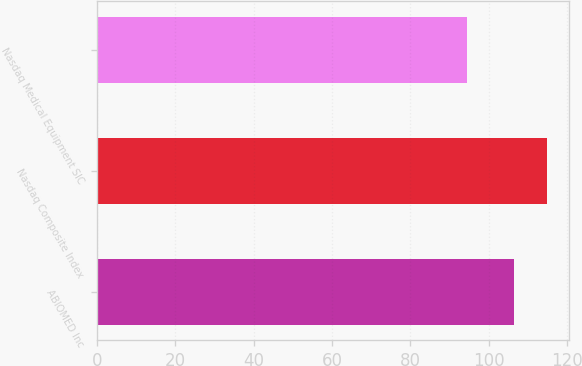<chart> <loc_0><loc_0><loc_500><loc_500><bar_chart><fcel>ABIOMED Inc<fcel>Nasdaq Composite Index<fcel>Nasdaq Medical Equipment SIC<nl><fcel>106.37<fcel>114.84<fcel>94.54<nl></chart> 